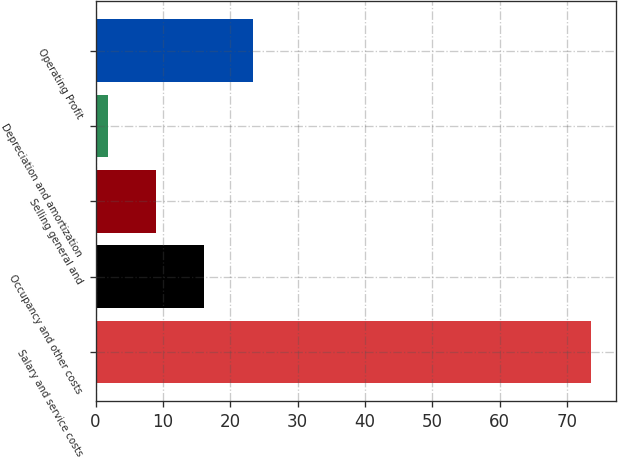Convert chart. <chart><loc_0><loc_0><loc_500><loc_500><bar_chart><fcel>Salary and service costs<fcel>Occupancy and other costs<fcel>Selling general and<fcel>Depreciation and amortization<fcel>Operating Profit<nl><fcel>73.5<fcel>16.14<fcel>8.97<fcel>1.8<fcel>23.31<nl></chart> 